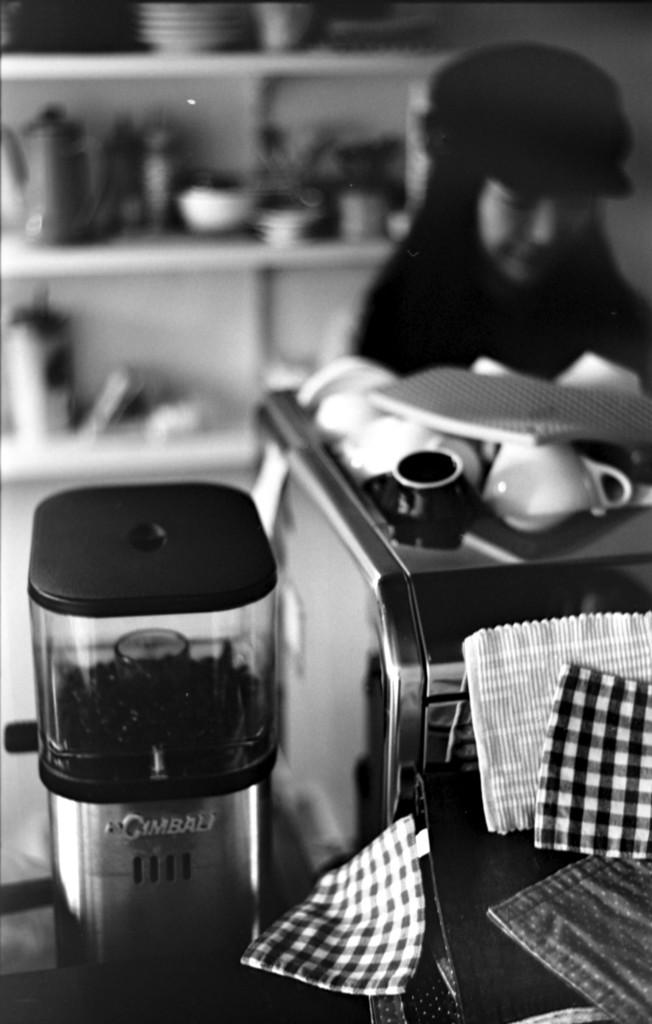<image>
Offer a succinct explanation of the picture presented. an item that has Gimbali written on it 